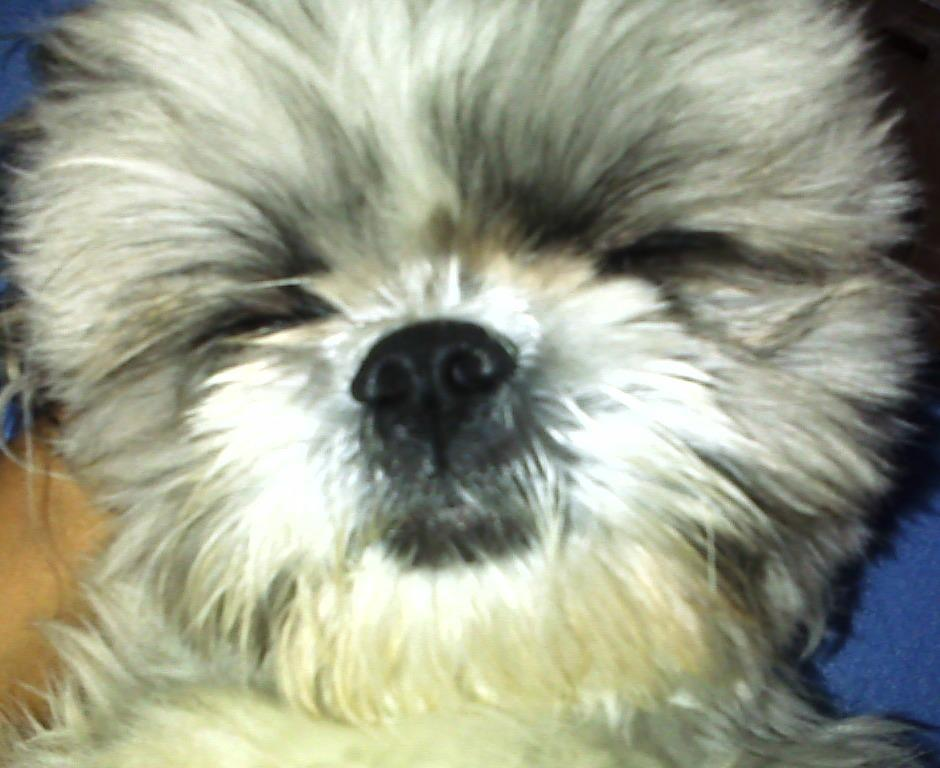What type of animal is in the image? There is a dog in the image. Can you describe the colors of the dog? The dog has white, cream, and black colors. What colors can be seen in the background of the image? The background of the image has blue and brown colors. What reward does the dog receive for making a decision in the image? There is no indication in the image that the dog is making a decision or receiving a reward. 